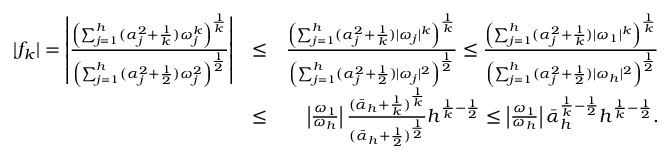<formula> <loc_0><loc_0><loc_500><loc_500>\begin{array} { r l r } { | f _ { k } | = \left | \frac { \left ( \sum _ { j = 1 } ^ { h } ( \alpha _ { j } ^ { 2 } + \frac { 1 } { k } ) \omega _ { j } ^ { k } \right ) ^ { \frac { 1 } { k } } } { \left ( \sum _ { j = 1 } ^ { h } ( \alpha _ { j } ^ { 2 } + \frac { 1 } { 2 } ) \omega _ { j } ^ { 2 } \right ) ^ { \frac { 1 } { 2 } } } \right | } & { \leq } & { \frac { \left ( \sum _ { j = 1 } ^ { h } ( \alpha _ { j } ^ { 2 } + \frac { 1 } { k } ) | \omega _ { j } | ^ { k } \right ) ^ { \frac { 1 } { k } } } { \left ( \sum _ { j = 1 } ^ { h } ( \alpha _ { j } ^ { 2 } + \frac { 1 } { 2 } ) | \omega _ { j } | ^ { 2 } \right ) ^ { \frac { 1 } { 2 } } } \leq \frac { \left ( \sum _ { j = 1 } ^ { h } ( \alpha _ { j } ^ { 2 } + \frac { 1 } { k } ) | \omega _ { 1 } | ^ { k } \right ) ^ { \frac { 1 } { k } } } { \left ( \sum _ { j = 1 } ^ { h } ( \alpha _ { j } ^ { 2 } + \frac { 1 } { 2 } ) | \omega _ { h } | ^ { 2 } \right ) ^ { \frac { 1 } { 2 } } } } \\ & { \leq } & { \left | \frac { \omega _ { 1 } } { \omega _ { h } } \right | \frac { ( \bar { \alpha } _ { h } + \frac { 1 } { k } ) ^ { \frac { 1 } { k } } } { ( \bar { \alpha } _ { h } + \frac { 1 } { 2 } ) ^ { \frac { 1 } { 2 } } } h ^ { \frac { 1 } { k } - \frac { 1 } { 2 } } \leq \left | \frac { \omega _ { 1 } } { \omega _ { h } } \right | \bar { \alpha } _ { h } ^ { \frac { 1 } { k } - \frac { 1 } { 2 } } h ^ { \frac { 1 } { k } - \frac { 1 } { 2 } } . } \end{array}</formula> 